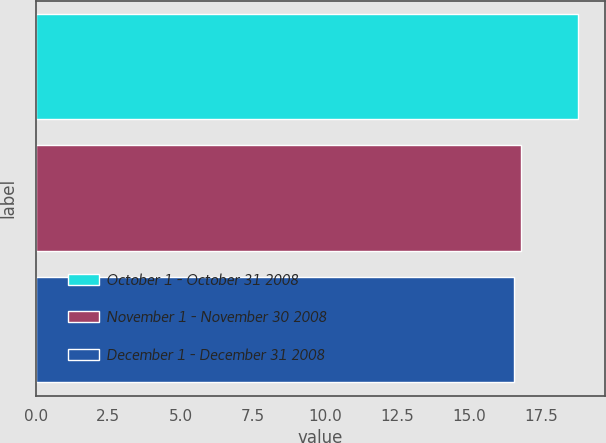<chart> <loc_0><loc_0><loc_500><loc_500><bar_chart><fcel>October 1 - October 31 2008<fcel>November 1 - November 30 2008<fcel>December 1 - December 31 2008<nl><fcel>18.77<fcel>16.79<fcel>16.57<nl></chart> 